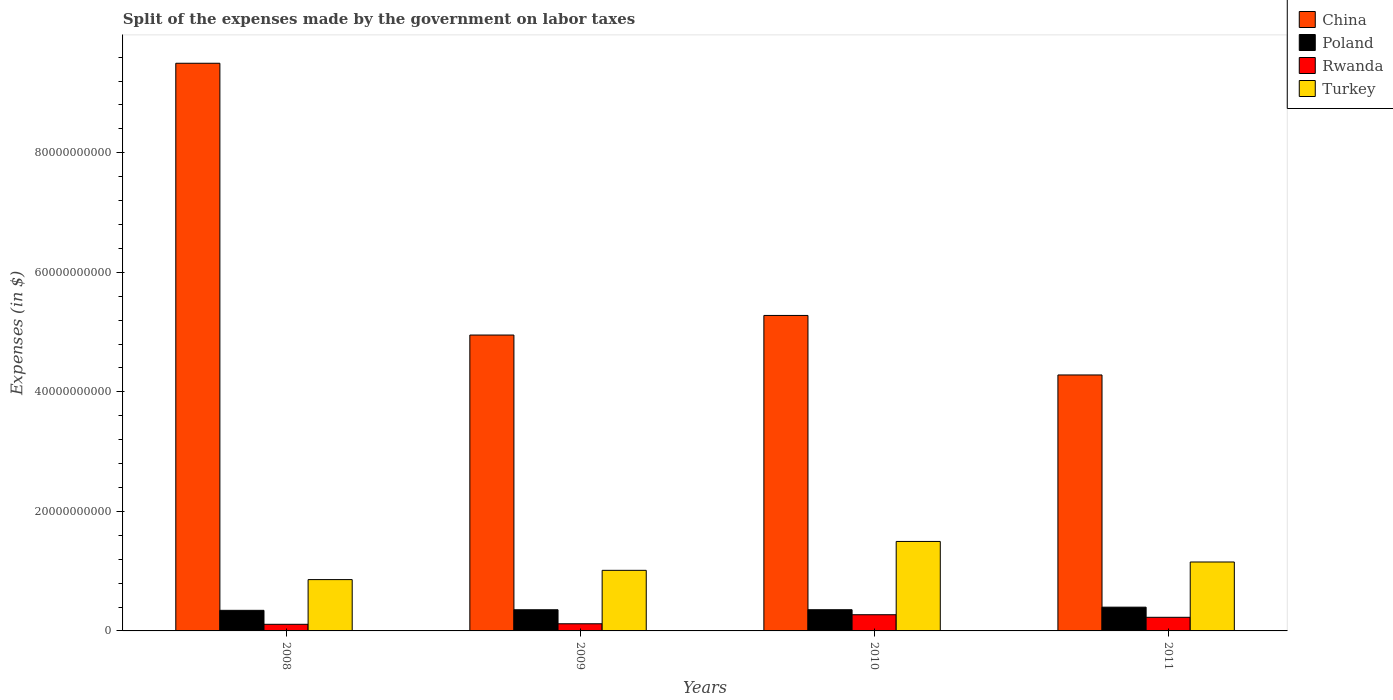Are the number of bars per tick equal to the number of legend labels?
Your answer should be compact. Yes. How many bars are there on the 2nd tick from the left?
Offer a terse response. 4. How many bars are there on the 3rd tick from the right?
Offer a terse response. 4. What is the expenses made by the government on labor taxes in Turkey in 2011?
Provide a short and direct response. 1.15e+1. Across all years, what is the maximum expenses made by the government on labor taxes in China?
Your answer should be compact. 9.50e+1. Across all years, what is the minimum expenses made by the government on labor taxes in Turkey?
Provide a short and direct response. 8.59e+09. In which year was the expenses made by the government on labor taxes in Poland minimum?
Provide a short and direct response. 2008. What is the total expenses made by the government on labor taxes in Rwanda in the graph?
Your answer should be very brief. 7.29e+09. What is the difference between the expenses made by the government on labor taxes in China in 2010 and that in 2011?
Give a very brief answer. 9.96e+09. What is the difference between the expenses made by the government on labor taxes in China in 2011 and the expenses made by the government on labor taxes in Turkey in 2008?
Your answer should be very brief. 3.42e+1. What is the average expenses made by the government on labor taxes in Poland per year?
Provide a succinct answer. 3.63e+09. In the year 2010, what is the difference between the expenses made by the government on labor taxes in China and expenses made by the government on labor taxes in Rwanda?
Make the answer very short. 5.01e+1. In how many years, is the expenses made by the government on labor taxes in Turkey greater than 16000000000 $?
Your answer should be compact. 0. What is the ratio of the expenses made by the government on labor taxes in Turkey in 2009 to that in 2010?
Ensure brevity in your answer.  0.68. Is the difference between the expenses made by the government on labor taxes in China in 2008 and 2011 greater than the difference between the expenses made by the government on labor taxes in Rwanda in 2008 and 2011?
Make the answer very short. Yes. What is the difference between the highest and the second highest expenses made by the government on labor taxes in Rwanda?
Provide a succinct answer. 4.31e+08. What is the difference between the highest and the lowest expenses made by the government on labor taxes in Turkey?
Provide a short and direct response. 6.39e+09. Is the sum of the expenses made by the government on labor taxes in Rwanda in 2009 and 2011 greater than the maximum expenses made by the government on labor taxes in Poland across all years?
Offer a very short reply. No. Is it the case that in every year, the sum of the expenses made by the government on labor taxes in Rwanda and expenses made by the government on labor taxes in Poland is greater than the sum of expenses made by the government on labor taxes in Turkey and expenses made by the government on labor taxes in China?
Give a very brief answer. Yes. What does the 3rd bar from the left in 2011 represents?
Your answer should be compact. Rwanda. Is it the case that in every year, the sum of the expenses made by the government on labor taxes in Turkey and expenses made by the government on labor taxes in Poland is greater than the expenses made by the government on labor taxes in China?
Offer a terse response. No. How many bars are there?
Give a very brief answer. 16. What is the difference between two consecutive major ticks on the Y-axis?
Ensure brevity in your answer.  2.00e+1. Does the graph contain any zero values?
Your answer should be very brief. No. Does the graph contain grids?
Give a very brief answer. No. Where does the legend appear in the graph?
Give a very brief answer. Top right. How many legend labels are there?
Your answer should be compact. 4. How are the legend labels stacked?
Your response must be concise. Vertical. What is the title of the graph?
Give a very brief answer. Split of the expenses made by the government on labor taxes. What is the label or title of the X-axis?
Your answer should be compact. Years. What is the label or title of the Y-axis?
Offer a very short reply. Expenses (in $). What is the Expenses (in $) of China in 2008?
Offer a terse response. 9.50e+1. What is the Expenses (in $) in Poland in 2008?
Your response must be concise. 3.44e+09. What is the Expenses (in $) of Rwanda in 2008?
Your answer should be very brief. 1.11e+09. What is the Expenses (in $) in Turkey in 2008?
Give a very brief answer. 8.59e+09. What is the Expenses (in $) in China in 2009?
Your response must be concise. 4.95e+1. What is the Expenses (in $) in Poland in 2009?
Offer a terse response. 3.54e+09. What is the Expenses (in $) in Rwanda in 2009?
Offer a very short reply. 1.20e+09. What is the Expenses (in $) in Turkey in 2009?
Your answer should be very brief. 1.01e+1. What is the Expenses (in $) in China in 2010?
Provide a succinct answer. 5.28e+1. What is the Expenses (in $) in Poland in 2010?
Your answer should be very brief. 3.55e+09. What is the Expenses (in $) of Rwanda in 2010?
Provide a short and direct response. 2.71e+09. What is the Expenses (in $) of Turkey in 2010?
Your answer should be very brief. 1.50e+1. What is the Expenses (in $) in China in 2011?
Provide a succinct answer. 4.28e+1. What is the Expenses (in $) of Poland in 2011?
Offer a terse response. 3.98e+09. What is the Expenses (in $) of Rwanda in 2011?
Provide a short and direct response. 2.28e+09. What is the Expenses (in $) of Turkey in 2011?
Give a very brief answer. 1.15e+1. Across all years, what is the maximum Expenses (in $) of China?
Make the answer very short. 9.50e+1. Across all years, what is the maximum Expenses (in $) of Poland?
Provide a short and direct response. 3.98e+09. Across all years, what is the maximum Expenses (in $) of Rwanda?
Your answer should be very brief. 2.71e+09. Across all years, what is the maximum Expenses (in $) of Turkey?
Your answer should be very brief. 1.50e+1. Across all years, what is the minimum Expenses (in $) in China?
Provide a succinct answer. 4.28e+1. Across all years, what is the minimum Expenses (in $) of Poland?
Your answer should be very brief. 3.44e+09. Across all years, what is the minimum Expenses (in $) of Rwanda?
Your answer should be very brief. 1.11e+09. Across all years, what is the minimum Expenses (in $) of Turkey?
Offer a terse response. 8.59e+09. What is the total Expenses (in $) of China in the graph?
Keep it short and to the point. 2.40e+11. What is the total Expenses (in $) of Poland in the graph?
Ensure brevity in your answer.  1.45e+1. What is the total Expenses (in $) in Rwanda in the graph?
Offer a terse response. 7.29e+09. What is the total Expenses (in $) of Turkey in the graph?
Offer a terse response. 4.52e+1. What is the difference between the Expenses (in $) in China in 2008 and that in 2009?
Offer a very short reply. 4.55e+1. What is the difference between the Expenses (in $) of Poland in 2008 and that in 2009?
Your answer should be very brief. -9.50e+07. What is the difference between the Expenses (in $) in Rwanda in 2008 and that in 2009?
Your response must be concise. -8.79e+07. What is the difference between the Expenses (in $) of Turkey in 2008 and that in 2009?
Provide a succinct answer. -1.55e+09. What is the difference between the Expenses (in $) of China in 2008 and that in 2010?
Offer a very short reply. 4.22e+1. What is the difference between the Expenses (in $) of Poland in 2008 and that in 2010?
Give a very brief answer. -1.01e+08. What is the difference between the Expenses (in $) in Rwanda in 2008 and that in 2010?
Keep it short and to the point. -1.60e+09. What is the difference between the Expenses (in $) in Turkey in 2008 and that in 2010?
Give a very brief answer. -6.39e+09. What is the difference between the Expenses (in $) of China in 2008 and that in 2011?
Your answer should be compact. 5.22e+1. What is the difference between the Expenses (in $) in Poland in 2008 and that in 2011?
Make the answer very short. -5.31e+08. What is the difference between the Expenses (in $) in Rwanda in 2008 and that in 2011?
Offer a very short reply. -1.17e+09. What is the difference between the Expenses (in $) of Turkey in 2008 and that in 2011?
Your response must be concise. -2.95e+09. What is the difference between the Expenses (in $) in China in 2009 and that in 2010?
Offer a very short reply. -3.28e+09. What is the difference between the Expenses (in $) of Poland in 2009 and that in 2010?
Provide a succinct answer. -6.00e+06. What is the difference between the Expenses (in $) of Rwanda in 2009 and that in 2010?
Keep it short and to the point. -1.51e+09. What is the difference between the Expenses (in $) of Turkey in 2009 and that in 2010?
Ensure brevity in your answer.  -4.84e+09. What is the difference between the Expenses (in $) in China in 2009 and that in 2011?
Provide a succinct answer. 6.68e+09. What is the difference between the Expenses (in $) in Poland in 2009 and that in 2011?
Keep it short and to the point. -4.36e+08. What is the difference between the Expenses (in $) in Rwanda in 2009 and that in 2011?
Provide a short and direct response. -1.08e+09. What is the difference between the Expenses (in $) in Turkey in 2009 and that in 2011?
Provide a succinct answer. -1.40e+09. What is the difference between the Expenses (in $) of China in 2010 and that in 2011?
Offer a terse response. 9.96e+09. What is the difference between the Expenses (in $) of Poland in 2010 and that in 2011?
Offer a terse response. -4.30e+08. What is the difference between the Expenses (in $) of Rwanda in 2010 and that in 2011?
Your answer should be compact. 4.31e+08. What is the difference between the Expenses (in $) in Turkey in 2010 and that in 2011?
Your response must be concise. 3.44e+09. What is the difference between the Expenses (in $) in China in 2008 and the Expenses (in $) in Poland in 2009?
Your answer should be very brief. 9.14e+1. What is the difference between the Expenses (in $) in China in 2008 and the Expenses (in $) in Rwanda in 2009?
Keep it short and to the point. 9.38e+1. What is the difference between the Expenses (in $) in China in 2008 and the Expenses (in $) in Turkey in 2009?
Make the answer very short. 8.48e+1. What is the difference between the Expenses (in $) of Poland in 2008 and the Expenses (in $) of Rwanda in 2009?
Your answer should be compact. 2.25e+09. What is the difference between the Expenses (in $) in Poland in 2008 and the Expenses (in $) in Turkey in 2009?
Keep it short and to the point. -6.69e+09. What is the difference between the Expenses (in $) of Rwanda in 2008 and the Expenses (in $) of Turkey in 2009?
Give a very brief answer. -9.03e+09. What is the difference between the Expenses (in $) of China in 2008 and the Expenses (in $) of Poland in 2010?
Keep it short and to the point. 9.14e+1. What is the difference between the Expenses (in $) in China in 2008 and the Expenses (in $) in Rwanda in 2010?
Provide a short and direct response. 9.23e+1. What is the difference between the Expenses (in $) of China in 2008 and the Expenses (in $) of Turkey in 2010?
Ensure brevity in your answer.  8.00e+1. What is the difference between the Expenses (in $) of Poland in 2008 and the Expenses (in $) of Rwanda in 2010?
Your response must be concise. 7.36e+08. What is the difference between the Expenses (in $) of Poland in 2008 and the Expenses (in $) of Turkey in 2010?
Ensure brevity in your answer.  -1.15e+1. What is the difference between the Expenses (in $) of Rwanda in 2008 and the Expenses (in $) of Turkey in 2010?
Your answer should be very brief. -1.39e+1. What is the difference between the Expenses (in $) in China in 2008 and the Expenses (in $) in Poland in 2011?
Offer a very short reply. 9.10e+1. What is the difference between the Expenses (in $) of China in 2008 and the Expenses (in $) of Rwanda in 2011?
Offer a very short reply. 9.27e+1. What is the difference between the Expenses (in $) in China in 2008 and the Expenses (in $) in Turkey in 2011?
Your response must be concise. 8.34e+1. What is the difference between the Expenses (in $) of Poland in 2008 and the Expenses (in $) of Rwanda in 2011?
Your answer should be very brief. 1.17e+09. What is the difference between the Expenses (in $) of Poland in 2008 and the Expenses (in $) of Turkey in 2011?
Offer a terse response. -8.09e+09. What is the difference between the Expenses (in $) of Rwanda in 2008 and the Expenses (in $) of Turkey in 2011?
Give a very brief answer. -1.04e+1. What is the difference between the Expenses (in $) of China in 2009 and the Expenses (in $) of Poland in 2010?
Your response must be concise. 4.60e+1. What is the difference between the Expenses (in $) in China in 2009 and the Expenses (in $) in Rwanda in 2010?
Offer a terse response. 4.68e+1. What is the difference between the Expenses (in $) in China in 2009 and the Expenses (in $) in Turkey in 2010?
Your response must be concise. 3.45e+1. What is the difference between the Expenses (in $) of Poland in 2009 and the Expenses (in $) of Rwanda in 2010?
Keep it short and to the point. 8.31e+08. What is the difference between the Expenses (in $) in Poland in 2009 and the Expenses (in $) in Turkey in 2010?
Make the answer very short. -1.14e+1. What is the difference between the Expenses (in $) in Rwanda in 2009 and the Expenses (in $) in Turkey in 2010?
Your answer should be very brief. -1.38e+1. What is the difference between the Expenses (in $) in China in 2009 and the Expenses (in $) in Poland in 2011?
Give a very brief answer. 4.55e+1. What is the difference between the Expenses (in $) in China in 2009 and the Expenses (in $) in Rwanda in 2011?
Keep it short and to the point. 4.72e+1. What is the difference between the Expenses (in $) in China in 2009 and the Expenses (in $) in Turkey in 2011?
Ensure brevity in your answer.  3.80e+1. What is the difference between the Expenses (in $) in Poland in 2009 and the Expenses (in $) in Rwanda in 2011?
Your response must be concise. 1.26e+09. What is the difference between the Expenses (in $) of Poland in 2009 and the Expenses (in $) of Turkey in 2011?
Make the answer very short. -7.99e+09. What is the difference between the Expenses (in $) in Rwanda in 2009 and the Expenses (in $) in Turkey in 2011?
Offer a very short reply. -1.03e+1. What is the difference between the Expenses (in $) in China in 2010 and the Expenses (in $) in Poland in 2011?
Offer a terse response. 4.88e+1. What is the difference between the Expenses (in $) of China in 2010 and the Expenses (in $) of Rwanda in 2011?
Make the answer very short. 5.05e+1. What is the difference between the Expenses (in $) in China in 2010 and the Expenses (in $) in Turkey in 2011?
Your answer should be very brief. 4.13e+1. What is the difference between the Expenses (in $) of Poland in 2010 and the Expenses (in $) of Rwanda in 2011?
Your answer should be compact. 1.27e+09. What is the difference between the Expenses (in $) in Poland in 2010 and the Expenses (in $) in Turkey in 2011?
Provide a short and direct response. -7.99e+09. What is the difference between the Expenses (in $) of Rwanda in 2010 and the Expenses (in $) of Turkey in 2011?
Give a very brief answer. -8.82e+09. What is the average Expenses (in $) of China per year?
Provide a short and direct response. 6.00e+1. What is the average Expenses (in $) of Poland per year?
Your response must be concise. 3.63e+09. What is the average Expenses (in $) of Rwanda per year?
Give a very brief answer. 1.82e+09. What is the average Expenses (in $) in Turkey per year?
Your answer should be compact. 1.13e+1. In the year 2008, what is the difference between the Expenses (in $) in China and Expenses (in $) in Poland?
Offer a terse response. 9.15e+1. In the year 2008, what is the difference between the Expenses (in $) in China and Expenses (in $) in Rwanda?
Your answer should be very brief. 9.39e+1. In the year 2008, what is the difference between the Expenses (in $) of China and Expenses (in $) of Turkey?
Your answer should be compact. 8.64e+1. In the year 2008, what is the difference between the Expenses (in $) of Poland and Expenses (in $) of Rwanda?
Your answer should be compact. 2.34e+09. In the year 2008, what is the difference between the Expenses (in $) of Poland and Expenses (in $) of Turkey?
Offer a very short reply. -5.14e+09. In the year 2008, what is the difference between the Expenses (in $) of Rwanda and Expenses (in $) of Turkey?
Give a very brief answer. -7.48e+09. In the year 2009, what is the difference between the Expenses (in $) of China and Expenses (in $) of Poland?
Provide a succinct answer. 4.60e+1. In the year 2009, what is the difference between the Expenses (in $) in China and Expenses (in $) in Rwanda?
Your answer should be very brief. 4.83e+1. In the year 2009, what is the difference between the Expenses (in $) of China and Expenses (in $) of Turkey?
Your answer should be compact. 3.94e+1. In the year 2009, what is the difference between the Expenses (in $) of Poland and Expenses (in $) of Rwanda?
Your answer should be compact. 2.34e+09. In the year 2009, what is the difference between the Expenses (in $) of Poland and Expenses (in $) of Turkey?
Keep it short and to the point. -6.60e+09. In the year 2009, what is the difference between the Expenses (in $) in Rwanda and Expenses (in $) in Turkey?
Provide a succinct answer. -8.94e+09. In the year 2010, what is the difference between the Expenses (in $) of China and Expenses (in $) of Poland?
Offer a very short reply. 4.92e+1. In the year 2010, what is the difference between the Expenses (in $) of China and Expenses (in $) of Rwanda?
Your answer should be compact. 5.01e+1. In the year 2010, what is the difference between the Expenses (in $) in China and Expenses (in $) in Turkey?
Offer a very short reply. 3.78e+1. In the year 2010, what is the difference between the Expenses (in $) of Poland and Expenses (in $) of Rwanda?
Make the answer very short. 8.37e+08. In the year 2010, what is the difference between the Expenses (in $) of Poland and Expenses (in $) of Turkey?
Offer a terse response. -1.14e+1. In the year 2010, what is the difference between the Expenses (in $) in Rwanda and Expenses (in $) in Turkey?
Your answer should be very brief. -1.23e+1. In the year 2011, what is the difference between the Expenses (in $) of China and Expenses (in $) of Poland?
Provide a short and direct response. 3.89e+1. In the year 2011, what is the difference between the Expenses (in $) of China and Expenses (in $) of Rwanda?
Keep it short and to the point. 4.05e+1. In the year 2011, what is the difference between the Expenses (in $) in China and Expenses (in $) in Turkey?
Your answer should be very brief. 3.13e+1. In the year 2011, what is the difference between the Expenses (in $) of Poland and Expenses (in $) of Rwanda?
Give a very brief answer. 1.70e+09. In the year 2011, what is the difference between the Expenses (in $) in Poland and Expenses (in $) in Turkey?
Provide a succinct answer. -7.56e+09. In the year 2011, what is the difference between the Expenses (in $) in Rwanda and Expenses (in $) in Turkey?
Give a very brief answer. -9.26e+09. What is the ratio of the Expenses (in $) in China in 2008 to that in 2009?
Your answer should be very brief. 1.92. What is the ratio of the Expenses (in $) of Poland in 2008 to that in 2009?
Your answer should be compact. 0.97. What is the ratio of the Expenses (in $) of Rwanda in 2008 to that in 2009?
Make the answer very short. 0.93. What is the ratio of the Expenses (in $) of Turkey in 2008 to that in 2009?
Make the answer very short. 0.85. What is the ratio of the Expenses (in $) in China in 2008 to that in 2010?
Your answer should be very brief. 1.8. What is the ratio of the Expenses (in $) in Poland in 2008 to that in 2010?
Provide a short and direct response. 0.97. What is the ratio of the Expenses (in $) of Rwanda in 2008 to that in 2010?
Your response must be concise. 0.41. What is the ratio of the Expenses (in $) of Turkey in 2008 to that in 2010?
Your answer should be very brief. 0.57. What is the ratio of the Expenses (in $) in China in 2008 to that in 2011?
Your response must be concise. 2.22. What is the ratio of the Expenses (in $) of Poland in 2008 to that in 2011?
Offer a terse response. 0.87. What is the ratio of the Expenses (in $) of Rwanda in 2008 to that in 2011?
Your answer should be very brief. 0.49. What is the ratio of the Expenses (in $) in Turkey in 2008 to that in 2011?
Offer a terse response. 0.74. What is the ratio of the Expenses (in $) of China in 2009 to that in 2010?
Provide a succinct answer. 0.94. What is the ratio of the Expenses (in $) of Rwanda in 2009 to that in 2010?
Provide a succinct answer. 0.44. What is the ratio of the Expenses (in $) of Turkey in 2009 to that in 2010?
Keep it short and to the point. 0.68. What is the ratio of the Expenses (in $) of China in 2009 to that in 2011?
Keep it short and to the point. 1.16. What is the ratio of the Expenses (in $) in Poland in 2009 to that in 2011?
Your answer should be very brief. 0.89. What is the ratio of the Expenses (in $) in Rwanda in 2009 to that in 2011?
Provide a succinct answer. 0.52. What is the ratio of the Expenses (in $) in Turkey in 2009 to that in 2011?
Give a very brief answer. 0.88. What is the ratio of the Expenses (in $) of China in 2010 to that in 2011?
Provide a succinct answer. 1.23. What is the ratio of the Expenses (in $) of Poland in 2010 to that in 2011?
Provide a short and direct response. 0.89. What is the ratio of the Expenses (in $) in Rwanda in 2010 to that in 2011?
Make the answer very short. 1.19. What is the ratio of the Expenses (in $) in Turkey in 2010 to that in 2011?
Make the answer very short. 1.3. What is the difference between the highest and the second highest Expenses (in $) of China?
Ensure brevity in your answer.  4.22e+1. What is the difference between the highest and the second highest Expenses (in $) of Poland?
Your answer should be very brief. 4.30e+08. What is the difference between the highest and the second highest Expenses (in $) of Rwanda?
Keep it short and to the point. 4.31e+08. What is the difference between the highest and the second highest Expenses (in $) of Turkey?
Your response must be concise. 3.44e+09. What is the difference between the highest and the lowest Expenses (in $) in China?
Make the answer very short. 5.22e+1. What is the difference between the highest and the lowest Expenses (in $) in Poland?
Keep it short and to the point. 5.31e+08. What is the difference between the highest and the lowest Expenses (in $) in Rwanda?
Make the answer very short. 1.60e+09. What is the difference between the highest and the lowest Expenses (in $) in Turkey?
Keep it short and to the point. 6.39e+09. 